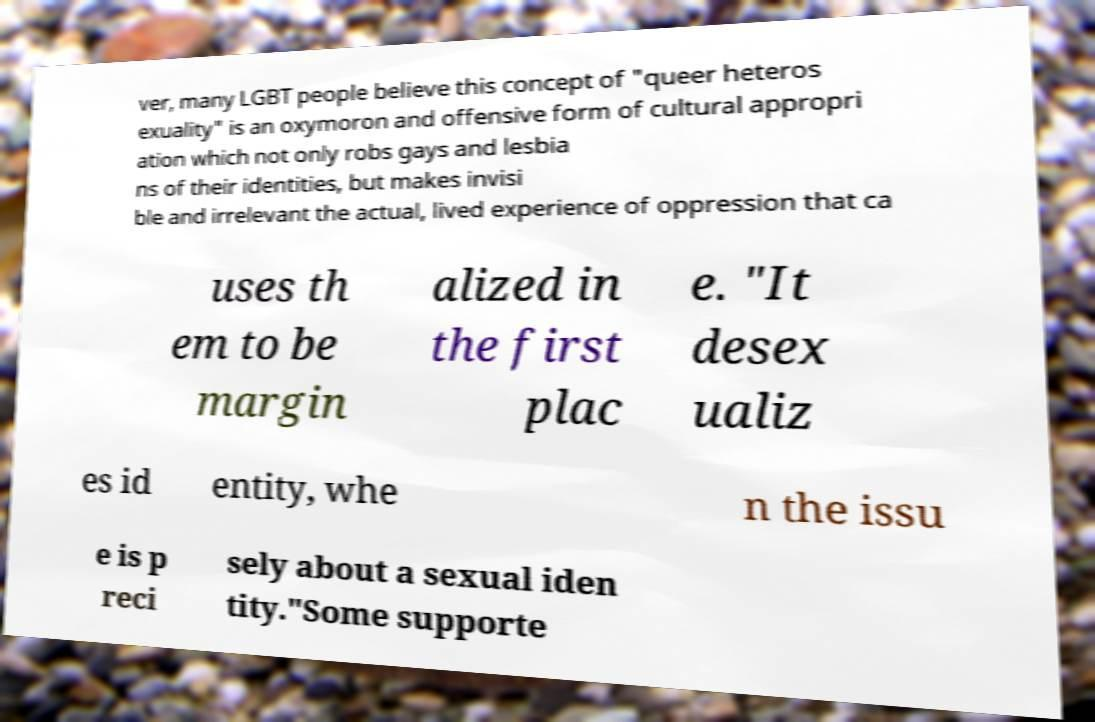Can you read and provide the text displayed in the image?This photo seems to have some interesting text. Can you extract and type it out for me? ver, many LGBT people believe this concept of "queer heteros exuality" is an oxymoron and offensive form of cultural appropri ation which not only robs gays and lesbia ns of their identities, but makes invisi ble and irrelevant the actual, lived experience of oppression that ca uses th em to be margin alized in the first plac e. "It desex ualiz es id entity, whe n the issu e is p reci sely about a sexual iden tity."Some supporte 